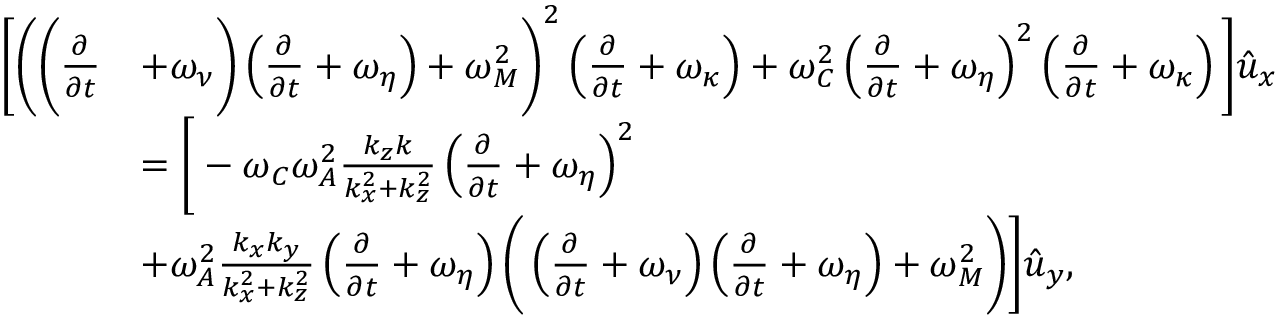<formula> <loc_0><loc_0><loc_500><loc_500>\begin{array} { r l } { \left [ \left ( \left ( \frac { \partial } { \partial { t } } } & { + \omega _ { \nu } \right ) \left ( \frac { \partial } { \partial { t } } + \omega _ { \eta } \right ) + \omega _ { M } ^ { 2 } \right ) ^ { 2 } \left ( \frac { \partial } { \partial { t } } + \omega _ { \kappa } \right ) + \omega _ { C } ^ { 2 } \left ( \frac { \partial } { \partial { t } } + \omega _ { \eta } \right ) ^ { 2 } \left ( \frac { \partial } { \partial { t } } + \omega _ { \kappa } \right ) \right ] \hat { u } _ { x } } \\ & { = \left [ - \omega _ { C } \omega _ { A } ^ { 2 } \frac { k _ { z } k } { k _ { x } ^ { 2 } + k _ { z } ^ { 2 } } \left ( \frac { \partial } { \partial { t } } + \omega _ { \eta } \right ) ^ { 2 } } \\ & { + \omega _ { A } ^ { 2 } \frac { k _ { x } k _ { y } } { k _ { x } ^ { 2 } + k _ { z } ^ { 2 } } \left ( \frac { \partial } { \partial { t } } + \omega _ { \eta } \right ) \left ( \left ( \frac { \partial } { \partial { t } } + \omega _ { \nu } \right ) \left ( \frac { \partial } { \partial { t } } + \omega _ { \eta } \right ) + \omega _ { M } ^ { 2 } \right ) \right ] \hat { u } _ { y } , } \end{array}</formula> 